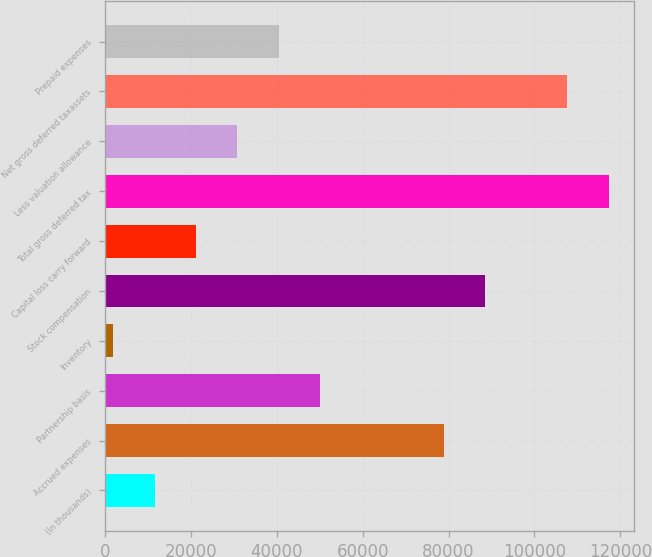Convert chart to OTSL. <chart><loc_0><loc_0><loc_500><loc_500><bar_chart><fcel>(In thousands)<fcel>Accrued expenses<fcel>Partnership basis<fcel>Inventory<fcel>Stock compensation<fcel>Capital loss carry forward<fcel>Total gross deferred tax<fcel>Less valuation allowance<fcel>Net gross deferred taxassets<fcel>Prepaid expenses<nl><fcel>11572.1<fcel>78856.8<fcel>50020.5<fcel>1960<fcel>88468.9<fcel>21184.2<fcel>117305<fcel>30796.3<fcel>107693<fcel>40408.4<nl></chart> 